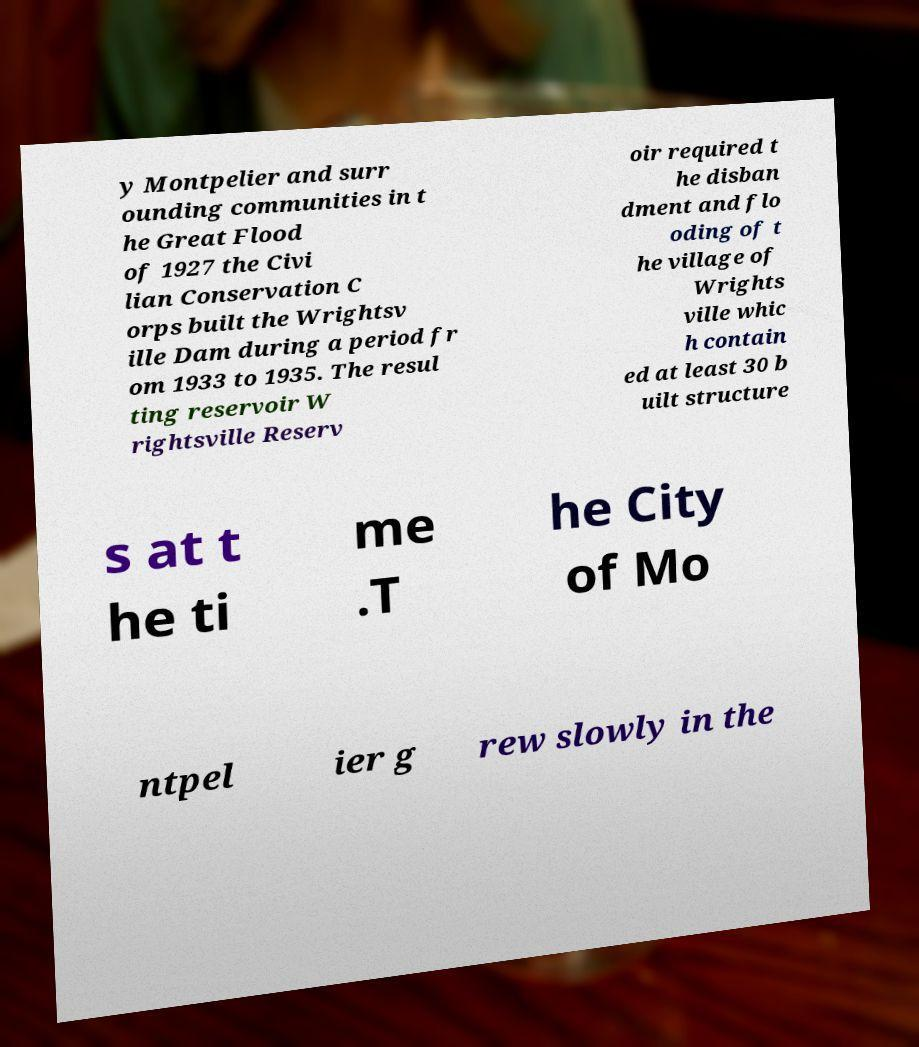There's text embedded in this image that I need extracted. Can you transcribe it verbatim? y Montpelier and surr ounding communities in t he Great Flood of 1927 the Civi lian Conservation C orps built the Wrightsv ille Dam during a period fr om 1933 to 1935. The resul ting reservoir W rightsville Reserv oir required t he disban dment and flo oding of t he village of Wrights ville whic h contain ed at least 30 b uilt structure s at t he ti me .T he City of Mo ntpel ier g rew slowly in the 